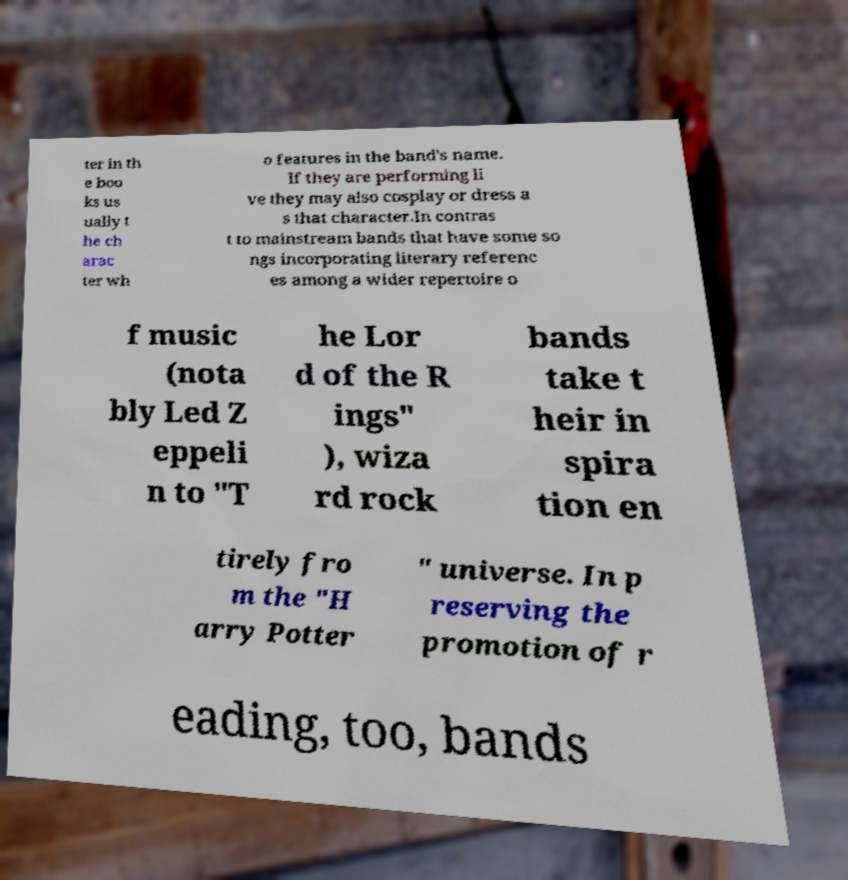What messages or text are displayed in this image? I need them in a readable, typed format. ter in th e boo ks us ually t he ch arac ter wh o features in the band's name. If they are performing li ve they may also cosplay or dress a s that character.In contras t to mainstream bands that have some so ngs incorporating literary referenc es among a wider repertoire o f music (nota bly Led Z eppeli n to "T he Lor d of the R ings" ), wiza rd rock bands take t heir in spira tion en tirely fro m the "H arry Potter " universe. In p reserving the promotion of r eading, too, bands 